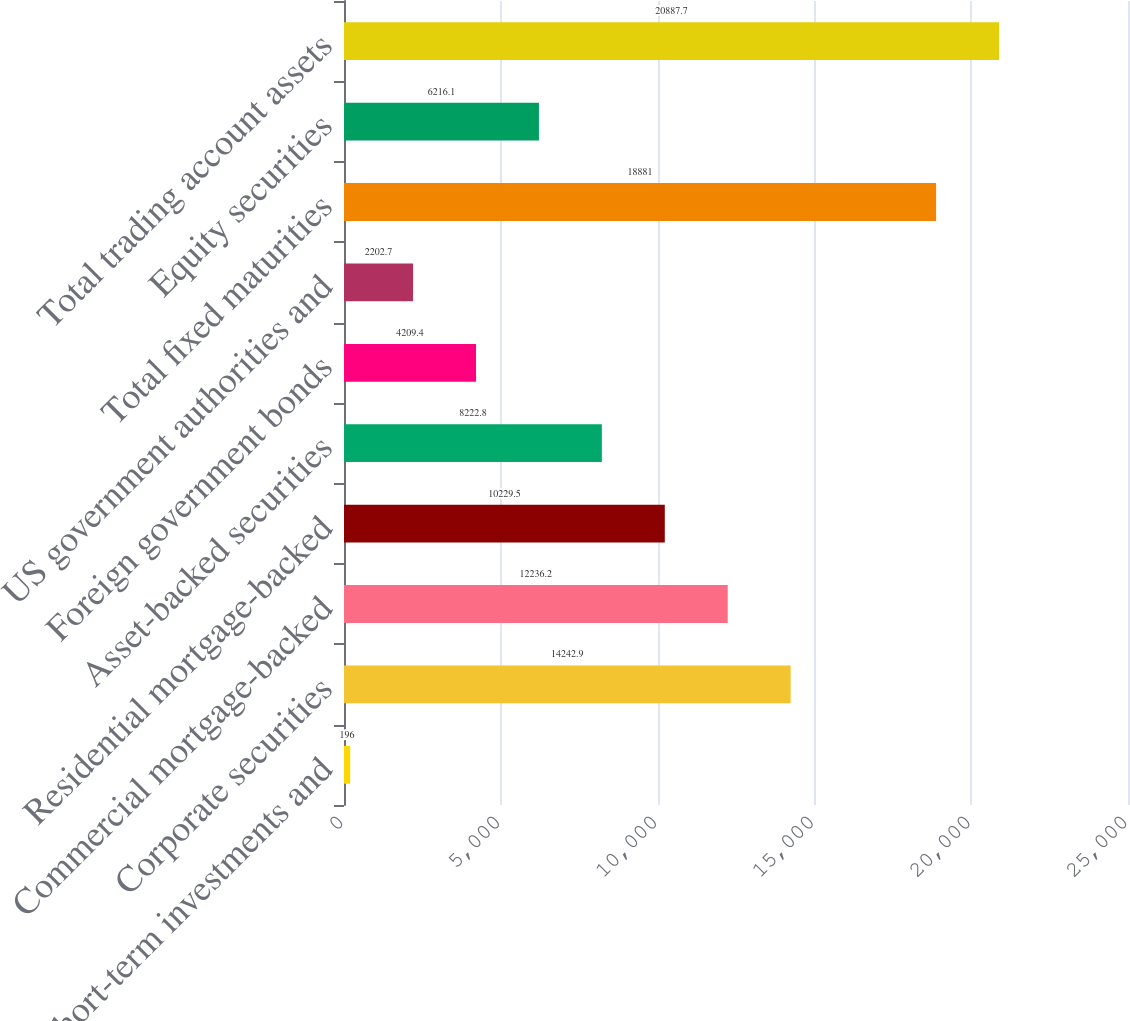Convert chart. <chart><loc_0><loc_0><loc_500><loc_500><bar_chart><fcel>Short-term investments and<fcel>Corporate securities<fcel>Commercial mortgage-backed<fcel>Residential mortgage-backed<fcel>Asset-backed securities<fcel>Foreign government bonds<fcel>US government authorities and<fcel>Total fixed maturities<fcel>Equity securities<fcel>Total trading account assets<nl><fcel>196<fcel>14242.9<fcel>12236.2<fcel>10229.5<fcel>8222.8<fcel>4209.4<fcel>2202.7<fcel>18881<fcel>6216.1<fcel>20887.7<nl></chart> 